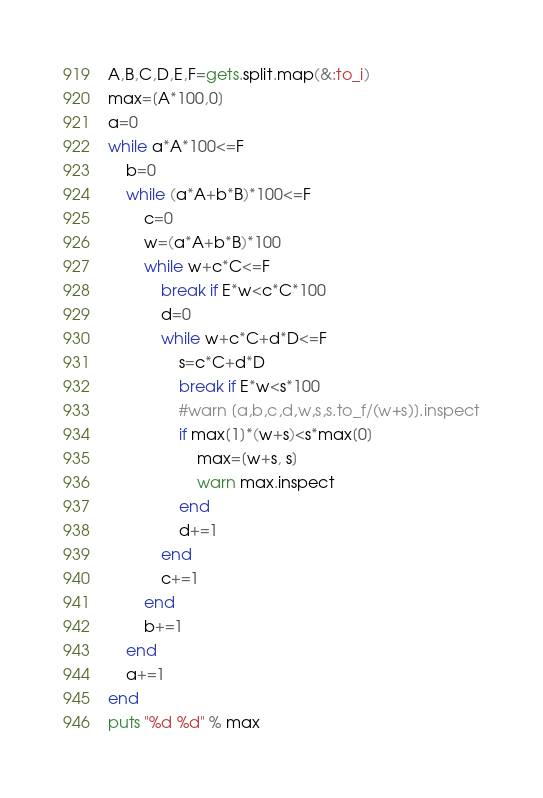<code> <loc_0><loc_0><loc_500><loc_500><_Ruby_>A,B,C,D,E,F=gets.split.map(&:to_i)
max=[A*100,0]
a=0
while a*A*100<=F
    b=0
    while (a*A+b*B)*100<=F
        c=0
        w=(a*A+b*B)*100
        while w+c*C<=F
            break if E*w<c*C*100
            d=0
            while w+c*C+d*D<=F
                s=c*C+d*D
                break if E*w<s*100
                #warn [a,b,c,d,w,s,s.to_f/(w+s)].inspect
                if max[1]*(w+s)<s*max[0]
                    max=[w+s, s]
                    warn max.inspect
                end
                d+=1
            end
            c+=1
        end
        b+=1
    end
    a+=1
end
puts "%d %d" % max
</code> 